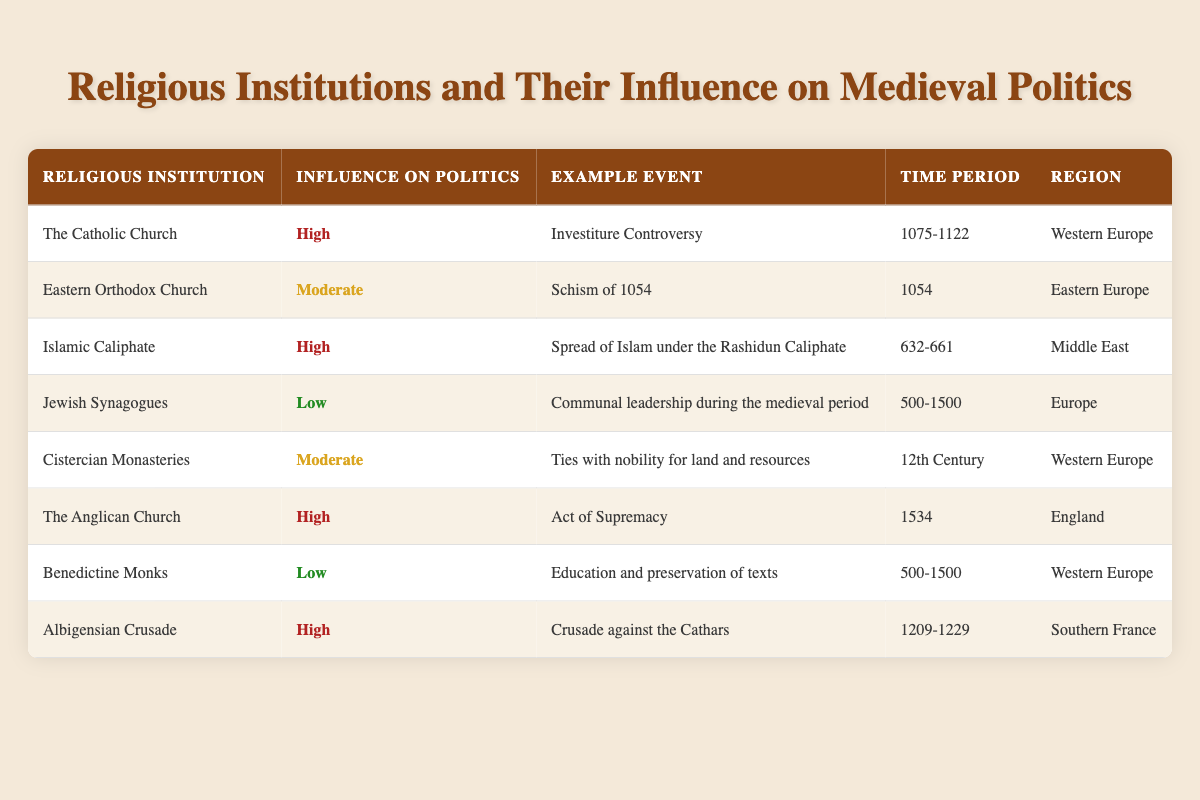What was the influence on politics of the Eastern Orthodox Church? The table indicates that the Eastern Orthodox Church had a "Moderate" influence on politics.
Answer: Moderate Which religious institution was involved in the Act of Supremacy? The table shows that the Anglican Church was involved in this event.
Answer: The Anglican Church Was the investment controversy linked to the Islamic Caliphate? Looking at the table, the Investiture Controversy is associated with the Catholic Church, not the Islamic Caliphate.
Answer: No How many religious institutions listed have a high influence on politics? By counting the rows marked as "High," there are four institutions: the Catholic Church, Islamic Caliphate, the Anglican Church, and the Albigensian Crusade.
Answer: 4 Which religious institution had its influence on politics labeled as low, and what was the example event? The table shows Jewish Synagogues with a low influence, and the example event is "Communal leadership during the medieval period."
Answer: Jewish Synagogues; Communal leadership during the medieval period What time period did the Cistercian Monasteries have a moderate influence on politics? The table states that the Cistercian Monasteries had a moderate influence during the 12th Century.
Answer: 12th Century Which region experienced high political influence from the Albigensian Crusade? The table indicates the region is Southern France for the Albigensian Crusade's high political influence.
Answer: Southern France List all religious institutions that had a moderate influence on politics. The table lists Cistercian Monasteries and the Eastern Orthodox Church as having moderate influence.
Answer: Cistercian Monasteries, Eastern Orthodox Church What was the example event connected with the high political influence of the Catholic Church? According to the table, the example event is the "Investiture Controversy."
Answer: Investiture Controversy Which religious institution in Western Europe had a high influence on medieval politics recently and what was the significant event? The Anglican Church had a high influence as of 1534 due to the Act of Supremacy.
Answer: The Anglican Church; Act of Supremacy 